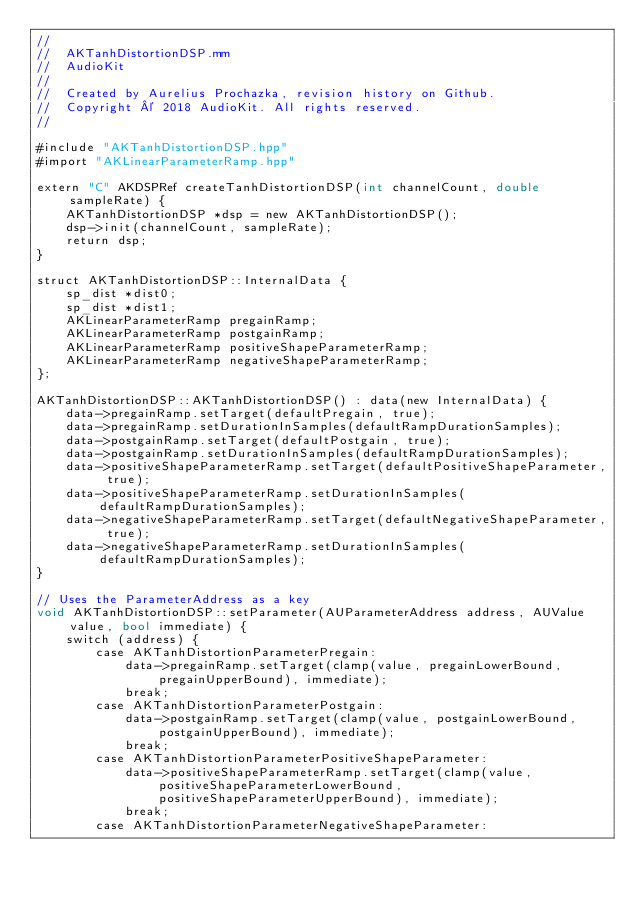Convert code to text. <code><loc_0><loc_0><loc_500><loc_500><_ObjectiveC_>//
//  AKTanhDistortionDSP.mm
//  AudioKit
//
//  Created by Aurelius Prochazka, revision history on Github.
//  Copyright © 2018 AudioKit. All rights reserved.
//

#include "AKTanhDistortionDSP.hpp"
#import "AKLinearParameterRamp.hpp"

extern "C" AKDSPRef createTanhDistortionDSP(int channelCount, double sampleRate) {
    AKTanhDistortionDSP *dsp = new AKTanhDistortionDSP();
    dsp->init(channelCount, sampleRate);
    return dsp;
}

struct AKTanhDistortionDSP::InternalData {
    sp_dist *dist0;
    sp_dist *dist1;
    AKLinearParameterRamp pregainRamp;
    AKLinearParameterRamp postgainRamp;
    AKLinearParameterRamp positiveShapeParameterRamp;
    AKLinearParameterRamp negativeShapeParameterRamp;
};

AKTanhDistortionDSP::AKTanhDistortionDSP() : data(new InternalData) {
    data->pregainRamp.setTarget(defaultPregain, true);
    data->pregainRamp.setDurationInSamples(defaultRampDurationSamples);
    data->postgainRamp.setTarget(defaultPostgain, true);
    data->postgainRamp.setDurationInSamples(defaultRampDurationSamples);
    data->positiveShapeParameterRamp.setTarget(defaultPositiveShapeParameter, true);
    data->positiveShapeParameterRamp.setDurationInSamples(defaultRampDurationSamples);
    data->negativeShapeParameterRamp.setTarget(defaultNegativeShapeParameter, true);
    data->negativeShapeParameterRamp.setDurationInSamples(defaultRampDurationSamples);
}

// Uses the ParameterAddress as a key
void AKTanhDistortionDSP::setParameter(AUParameterAddress address, AUValue value, bool immediate) {
    switch (address) {
        case AKTanhDistortionParameterPregain:
            data->pregainRamp.setTarget(clamp(value, pregainLowerBound, pregainUpperBound), immediate);
            break;
        case AKTanhDistortionParameterPostgain:
            data->postgainRamp.setTarget(clamp(value, postgainLowerBound, postgainUpperBound), immediate);
            break;
        case AKTanhDistortionParameterPositiveShapeParameter:
            data->positiveShapeParameterRamp.setTarget(clamp(value, positiveShapeParameterLowerBound, positiveShapeParameterUpperBound), immediate);
            break;
        case AKTanhDistortionParameterNegativeShapeParameter:</code> 